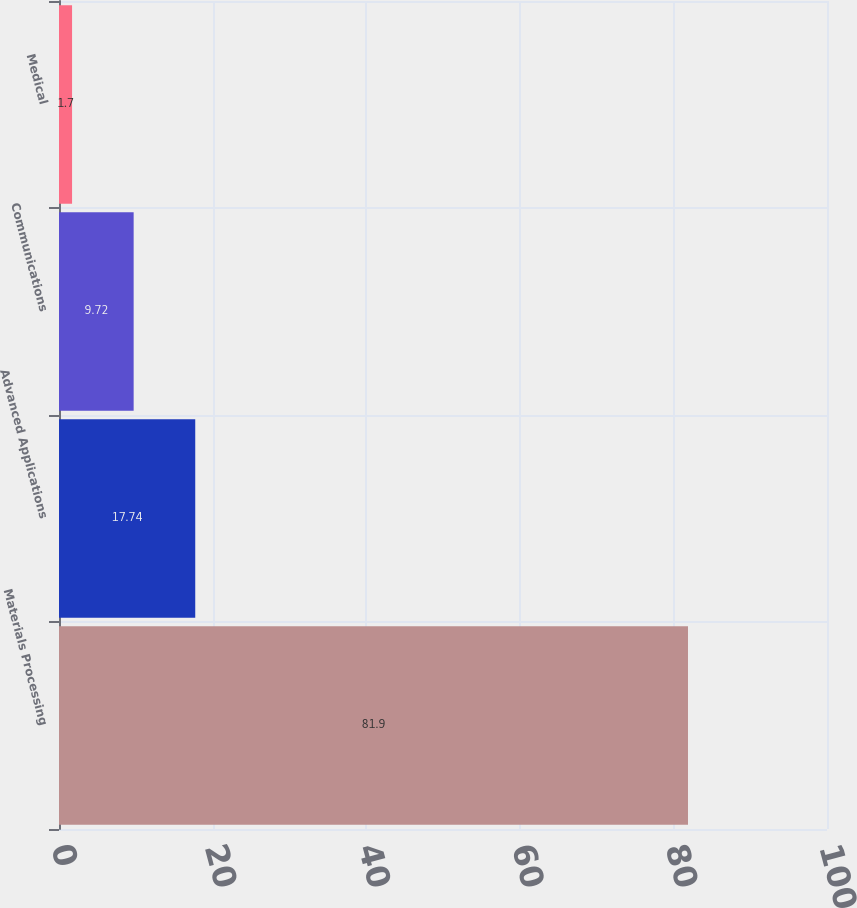<chart> <loc_0><loc_0><loc_500><loc_500><bar_chart><fcel>Materials Processing<fcel>Advanced Applications<fcel>Communications<fcel>Medical<nl><fcel>81.9<fcel>17.74<fcel>9.72<fcel>1.7<nl></chart> 